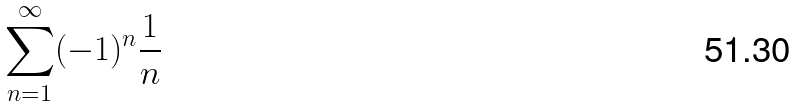<formula> <loc_0><loc_0><loc_500><loc_500>\sum _ { n = 1 } ^ { \infty } ( - 1 ) ^ { n } \frac { 1 } { n }</formula> 